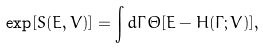<formula> <loc_0><loc_0><loc_500><loc_500>\exp [ S ( E , V ) ] = \int d \Gamma \, \Theta [ E - H ( \Gamma ; V ) ] ,</formula> 